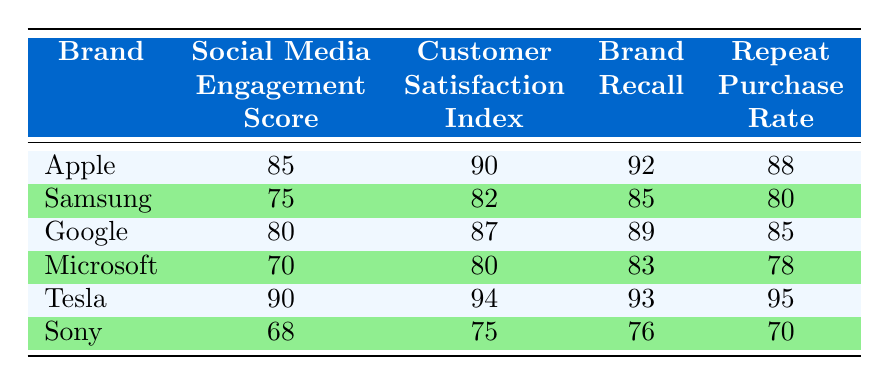What's the social media engagement score of Tesla? The table shows that Tesla has a social media engagement score of 90.
Answer: 90 Which brand has the highest customer satisfaction index? Looking through the customer satisfaction index values, Tesla has the highest score of 94.
Answer: Tesla What's the repeat purchase rate of Samsung? The table indicates that Samsung has a repeat purchase rate of 80.
Answer: 80 Is Apple's brand recall higher than Google's? Apple's brand recall is 92 while Google's is 89, so yes, Apple’s is higher.
Answer: Yes What is the average social media engagement score for the brands listed? To find the average, sum the scores: 85 + 75 + 80 + 70 + 90 + 68 = 468, and divide by the number of brands, which is 6: 468 / 6 = 78.
Answer: 78 Which brand has the lowest repeat purchase rate, and what is the value? By examining the repeat purchase rates, Sony has the lowest value of 70.
Answer: Sony, 70 If we consider brand loyalty to be a combination of customer satisfaction, brand recall, and repeat purchase rate, which brand demonstrates the highest total score for these indicators? First, calculate the total score for each brand by adding customer satisfaction index, brand recall, and repeat purchase rate. For Tesla: 94 + 93 + 95 = 282, for Apple: 90 + 92 + 88 = 270, and so on. The highest total score is for Tesla with 282.
Answer: Tesla, 282 Is there a correlation between social media engagement score and repeat purchase rate among these brands? By observing the values, as the social media engagement score increases, the repeat purchase rate typically also increases, suggesting a positive correlation, although a specific correlation coefficient isn't calculated.
Answer: Yes What is the difference in brand recall between Microsoft and Sony? Microsoft has a brand recall of 83, and Sony has 76. The difference is 83 - 76 = 7.
Answer: 7 